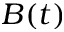<formula> <loc_0><loc_0><loc_500><loc_500>B ( t )</formula> 